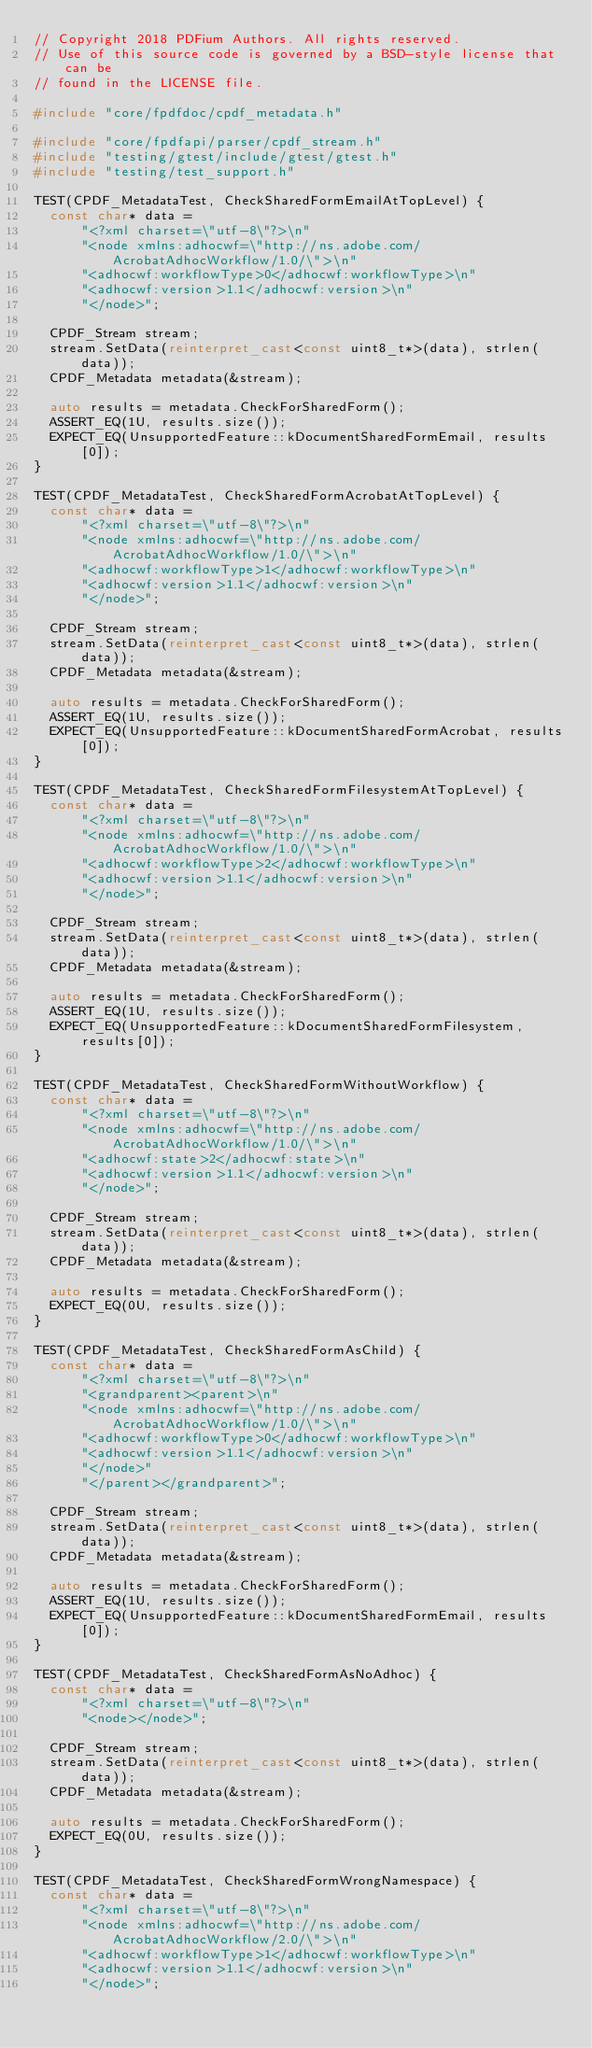<code> <loc_0><loc_0><loc_500><loc_500><_C++_>// Copyright 2018 PDFium Authors. All rights reserved.
// Use of this source code is governed by a BSD-style license that can be
// found in the LICENSE file.

#include "core/fpdfdoc/cpdf_metadata.h"

#include "core/fpdfapi/parser/cpdf_stream.h"
#include "testing/gtest/include/gtest/gtest.h"
#include "testing/test_support.h"

TEST(CPDF_MetadataTest, CheckSharedFormEmailAtTopLevel) {
  const char* data =
      "<?xml charset=\"utf-8\"?>\n"
      "<node xmlns:adhocwf=\"http://ns.adobe.com/AcrobatAdhocWorkflow/1.0/\">\n"
      "<adhocwf:workflowType>0</adhocwf:workflowType>\n"
      "<adhocwf:version>1.1</adhocwf:version>\n"
      "</node>";

  CPDF_Stream stream;
  stream.SetData(reinterpret_cast<const uint8_t*>(data), strlen(data));
  CPDF_Metadata metadata(&stream);

  auto results = metadata.CheckForSharedForm();
  ASSERT_EQ(1U, results.size());
  EXPECT_EQ(UnsupportedFeature::kDocumentSharedFormEmail, results[0]);
}

TEST(CPDF_MetadataTest, CheckSharedFormAcrobatAtTopLevel) {
  const char* data =
      "<?xml charset=\"utf-8\"?>\n"
      "<node xmlns:adhocwf=\"http://ns.adobe.com/AcrobatAdhocWorkflow/1.0/\">\n"
      "<adhocwf:workflowType>1</adhocwf:workflowType>\n"
      "<adhocwf:version>1.1</adhocwf:version>\n"
      "</node>";

  CPDF_Stream stream;
  stream.SetData(reinterpret_cast<const uint8_t*>(data), strlen(data));
  CPDF_Metadata metadata(&stream);

  auto results = metadata.CheckForSharedForm();
  ASSERT_EQ(1U, results.size());
  EXPECT_EQ(UnsupportedFeature::kDocumentSharedFormAcrobat, results[0]);
}

TEST(CPDF_MetadataTest, CheckSharedFormFilesystemAtTopLevel) {
  const char* data =
      "<?xml charset=\"utf-8\"?>\n"
      "<node xmlns:adhocwf=\"http://ns.adobe.com/AcrobatAdhocWorkflow/1.0/\">\n"
      "<adhocwf:workflowType>2</adhocwf:workflowType>\n"
      "<adhocwf:version>1.1</adhocwf:version>\n"
      "</node>";

  CPDF_Stream stream;
  stream.SetData(reinterpret_cast<const uint8_t*>(data), strlen(data));
  CPDF_Metadata metadata(&stream);

  auto results = metadata.CheckForSharedForm();
  ASSERT_EQ(1U, results.size());
  EXPECT_EQ(UnsupportedFeature::kDocumentSharedFormFilesystem, results[0]);
}

TEST(CPDF_MetadataTest, CheckSharedFormWithoutWorkflow) {
  const char* data =
      "<?xml charset=\"utf-8\"?>\n"
      "<node xmlns:adhocwf=\"http://ns.adobe.com/AcrobatAdhocWorkflow/1.0/\">\n"
      "<adhocwf:state>2</adhocwf:state>\n"
      "<adhocwf:version>1.1</adhocwf:version>\n"
      "</node>";

  CPDF_Stream stream;
  stream.SetData(reinterpret_cast<const uint8_t*>(data), strlen(data));
  CPDF_Metadata metadata(&stream);

  auto results = metadata.CheckForSharedForm();
  EXPECT_EQ(0U, results.size());
}

TEST(CPDF_MetadataTest, CheckSharedFormAsChild) {
  const char* data =
      "<?xml charset=\"utf-8\"?>\n"
      "<grandparent><parent>\n"
      "<node xmlns:adhocwf=\"http://ns.adobe.com/AcrobatAdhocWorkflow/1.0/\">\n"
      "<adhocwf:workflowType>0</adhocwf:workflowType>\n"
      "<adhocwf:version>1.1</adhocwf:version>\n"
      "</node>"
      "</parent></grandparent>";

  CPDF_Stream stream;
  stream.SetData(reinterpret_cast<const uint8_t*>(data), strlen(data));
  CPDF_Metadata metadata(&stream);

  auto results = metadata.CheckForSharedForm();
  ASSERT_EQ(1U, results.size());
  EXPECT_EQ(UnsupportedFeature::kDocumentSharedFormEmail, results[0]);
}

TEST(CPDF_MetadataTest, CheckSharedFormAsNoAdhoc) {
  const char* data =
      "<?xml charset=\"utf-8\"?>\n"
      "<node></node>";

  CPDF_Stream stream;
  stream.SetData(reinterpret_cast<const uint8_t*>(data), strlen(data));
  CPDF_Metadata metadata(&stream);

  auto results = metadata.CheckForSharedForm();
  EXPECT_EQ(0U, results.size());
}

TEST(CPDF_MetadataTest, CheckSharedFormWrongNamespace) {
  const char* data =
      "<?xml charset=\"utf-8\"?>\n"
      "<node xmlns:adhocwf=\"http://ns.adobe.com/AcrobatAdhocWorkflow/2.0/\">\n"
      "<adhocwf:workflowType>1</adhocwf:workflowType>\n"
      "<adhocwf:version>1.1</adhocwf:version>\n"
      "</node>";
</code> 